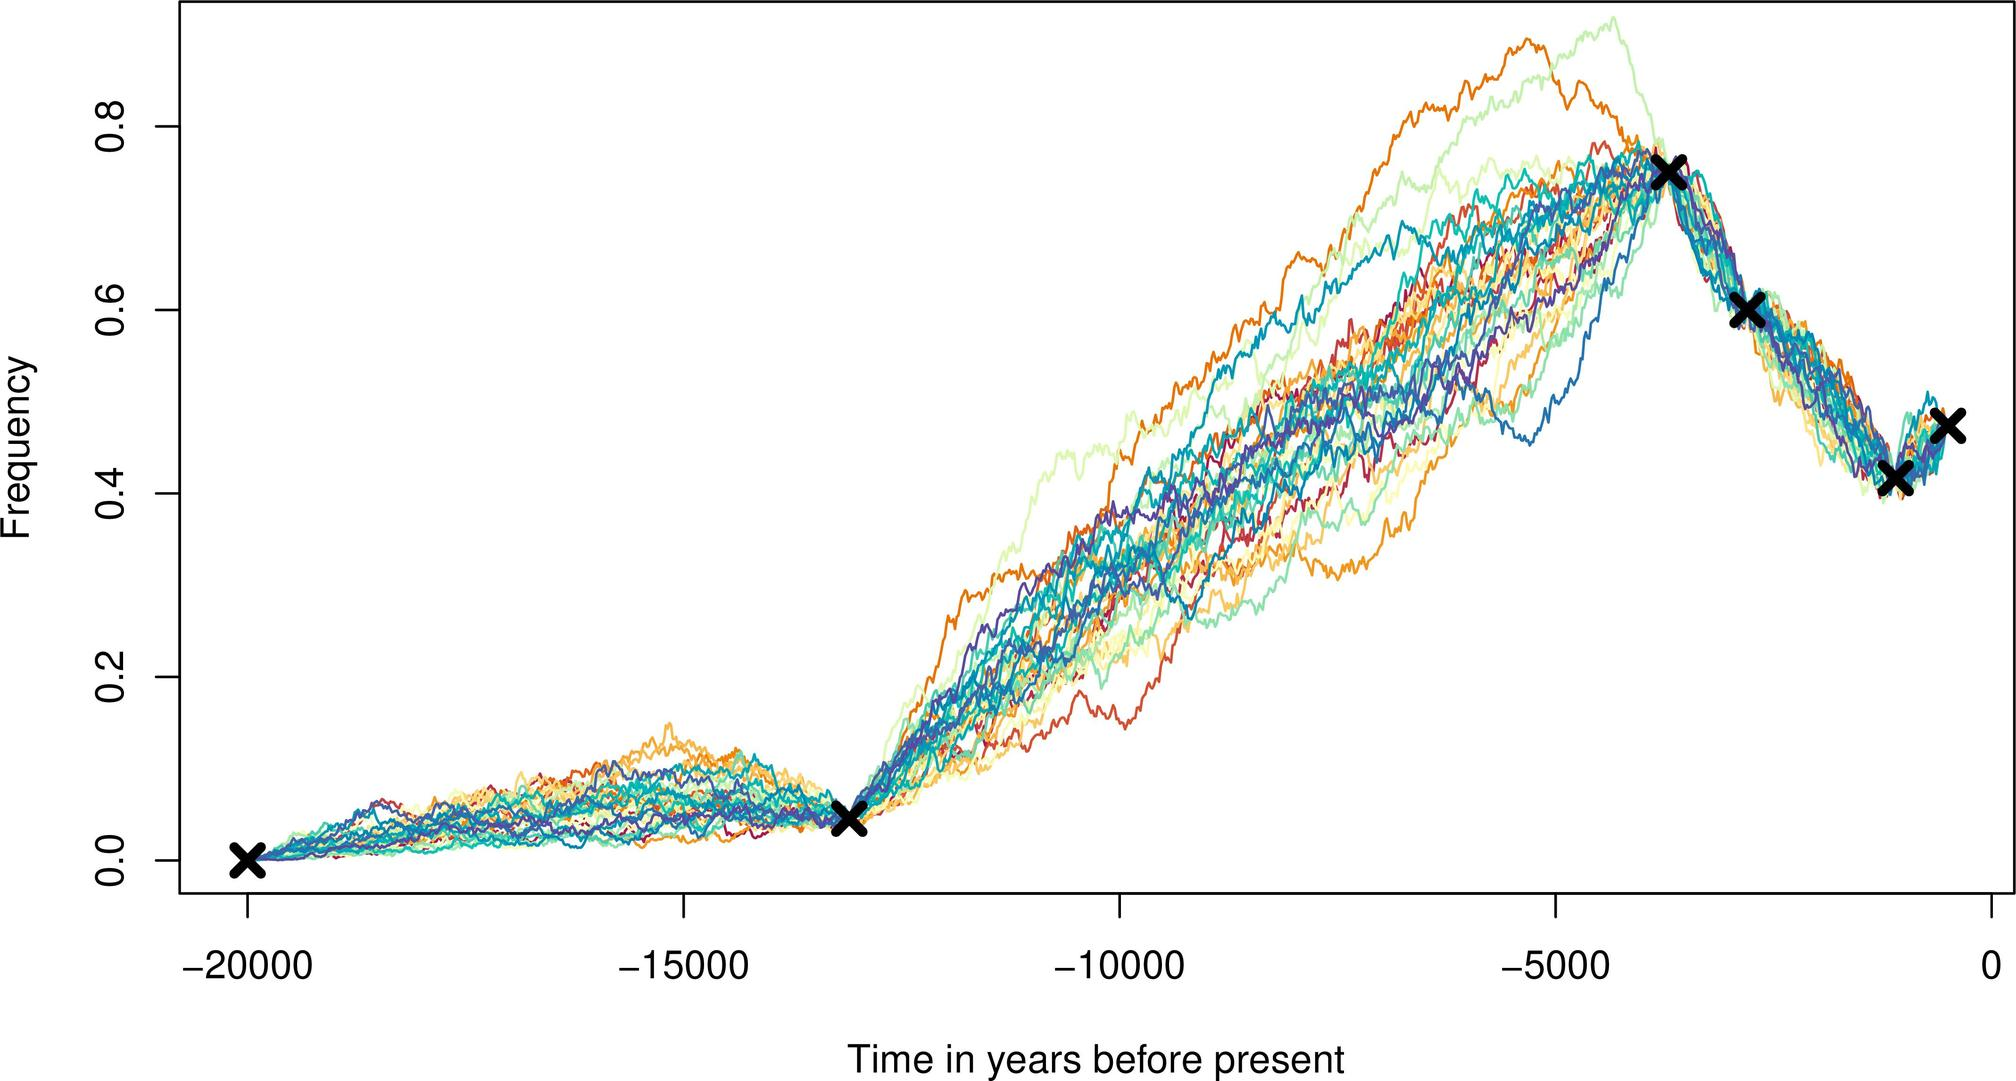Does the steep decline in frequency towards the present time suggest a negative event? The steep decline observed towards the present time might suggest a decrease in the frequency of the measured event or condition. This could be interpreted as the abatement of a once common phenomenon or the result of recent changes or interventions. However, characterizing it as 'negative' would depend on the context of the data - for example, a decrease in pollution levels would be positive, whereas a decline in biodiversity would be concerning.  Could the data indicate cyclic patterns over time? From the provided graph, there's a clear cyclic pattern leading up to the clustering, which suggests periodic fluctuations in the data. These cycles could be related to natural rhythms like glacial and interglacial periods, if it is climate data, or other recurring events. The regularity of these cycles could be analyzed to infer the causes and predict future patterns. 